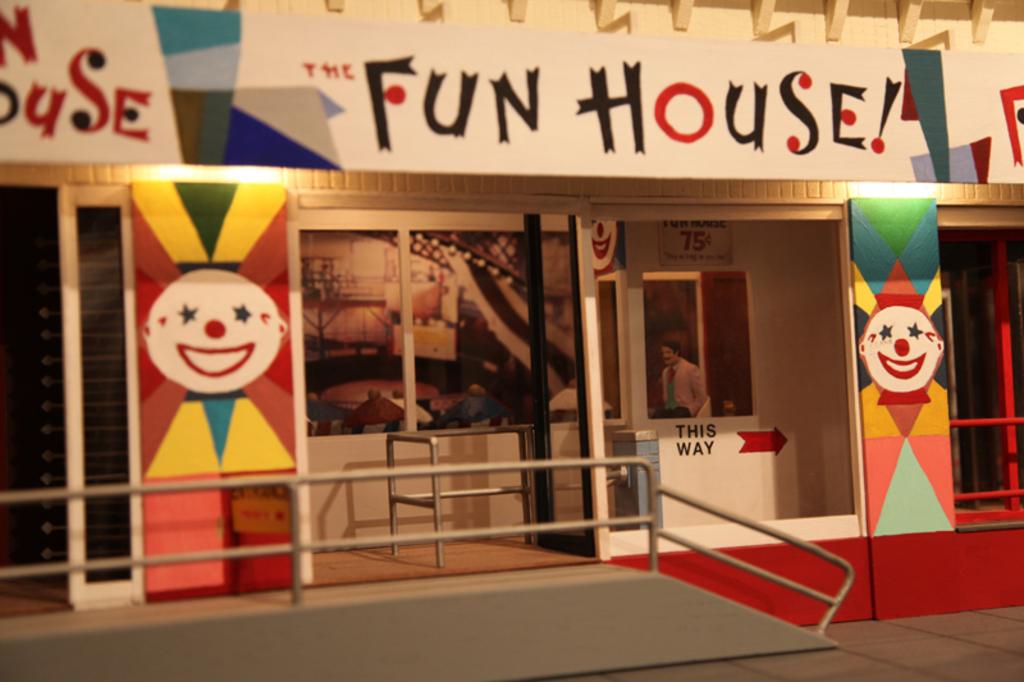Is this a fun house?
Give a very brief answer. Yes. What kind of ride is this?
Your answer should be compact. Fun house. 